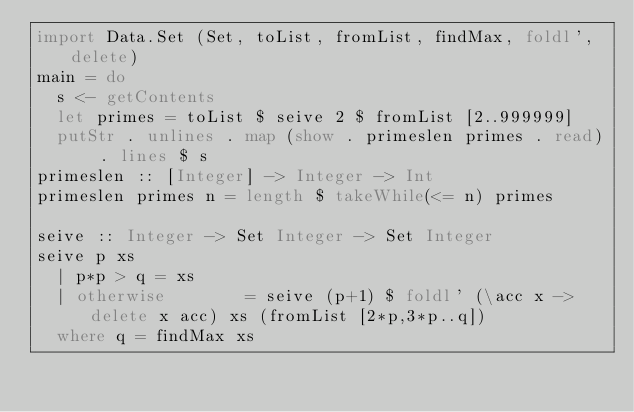<code> <loc_0><loc_0><loc_500><loc_500><_Haskell_>import Data.Set (Set, toList, fromList, findMax, foldl', delete)
main = do
  s <- getContents
  let primes = toList $ seive 2 $ fromList [2..999999]
  putStr . unlines . map (show . primeslen primes . read) . lines $ s
primeslen :: [Integer] -> Integer -> Int
primeslen primes n = length $ takeWhile(<= n) primes

seive :: Integer -> Set Integer -> Set Integer
seive p xs
  | p*p > q = xs
  | otherwise        = seive (p+1) $ foldl' (\acc x -> delete x acc) xs (fromList [2*p,3*p..q])
  where q = findMax xs</code> 